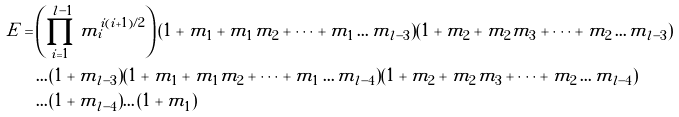<formula> <loc_0><loc_0><loc_500><loc_500>E = & \left ( \prod _ { i = 1 } ^ { l - 1 } m _ { i } ^ { i ( i + 1 ) / 2 } \right ) ( 1 + m _ { 1 } + m _ { 1 } m _ { 2 } + \dots + m _ { 1 } \dots m _ { l - 3 } ) ( 1 + m _ { 2 } + m _ { 2 } m _ { 3 } + \dots + m _ { 2 } \dots m _ { l - 3 } ) \\ & \dots ( 1 + m _ { l - 3 } ) ( 1 + m _ { 1 } + m _ { 1 } m _ { 2 } + \dots + m _ { 1 } \dots m _ { l - 4 } ) ( 1 + m _ { 2 } + m _ { 2 } m _ { 3 } + \dots + m _ { 2 } \dots m _ { l - 4 } ) \\ & \dots ( 1 + m _ { l - 4 } ) \dots ( 1 + m _ { 1 } )</formula> 